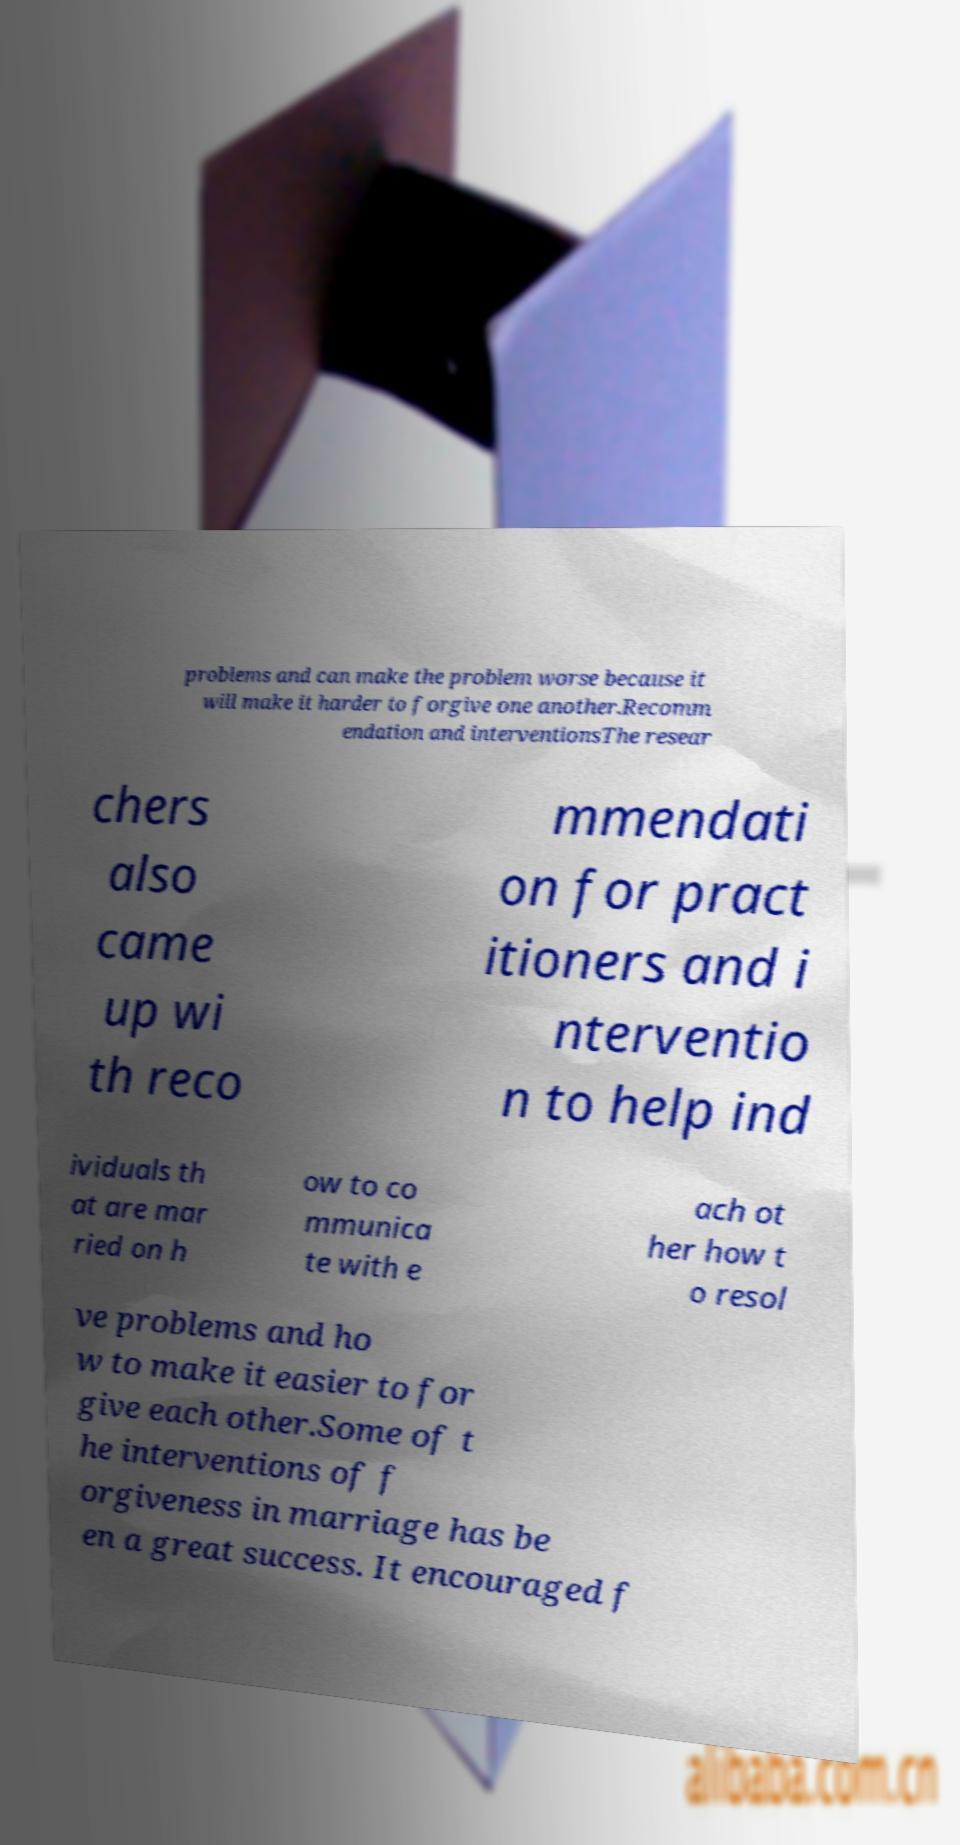There's text embedded in this image that I need extracted. Can you transcribe it verbatim? problems and can make the problem worse because it will make it harder to forgive one another.Recomm endation and interventionsThe resear chers also came up wi th reco mmendati on for pract itioners and i nterventio n to help ind ividuals th at are mar ried on h ow to co mmunica te with e ach ot her how t o resol ve problems and ho w to make it easier to for give each other.Some of t he interventions of f orgiveness in marriage has be en a great success. It encouraged f 